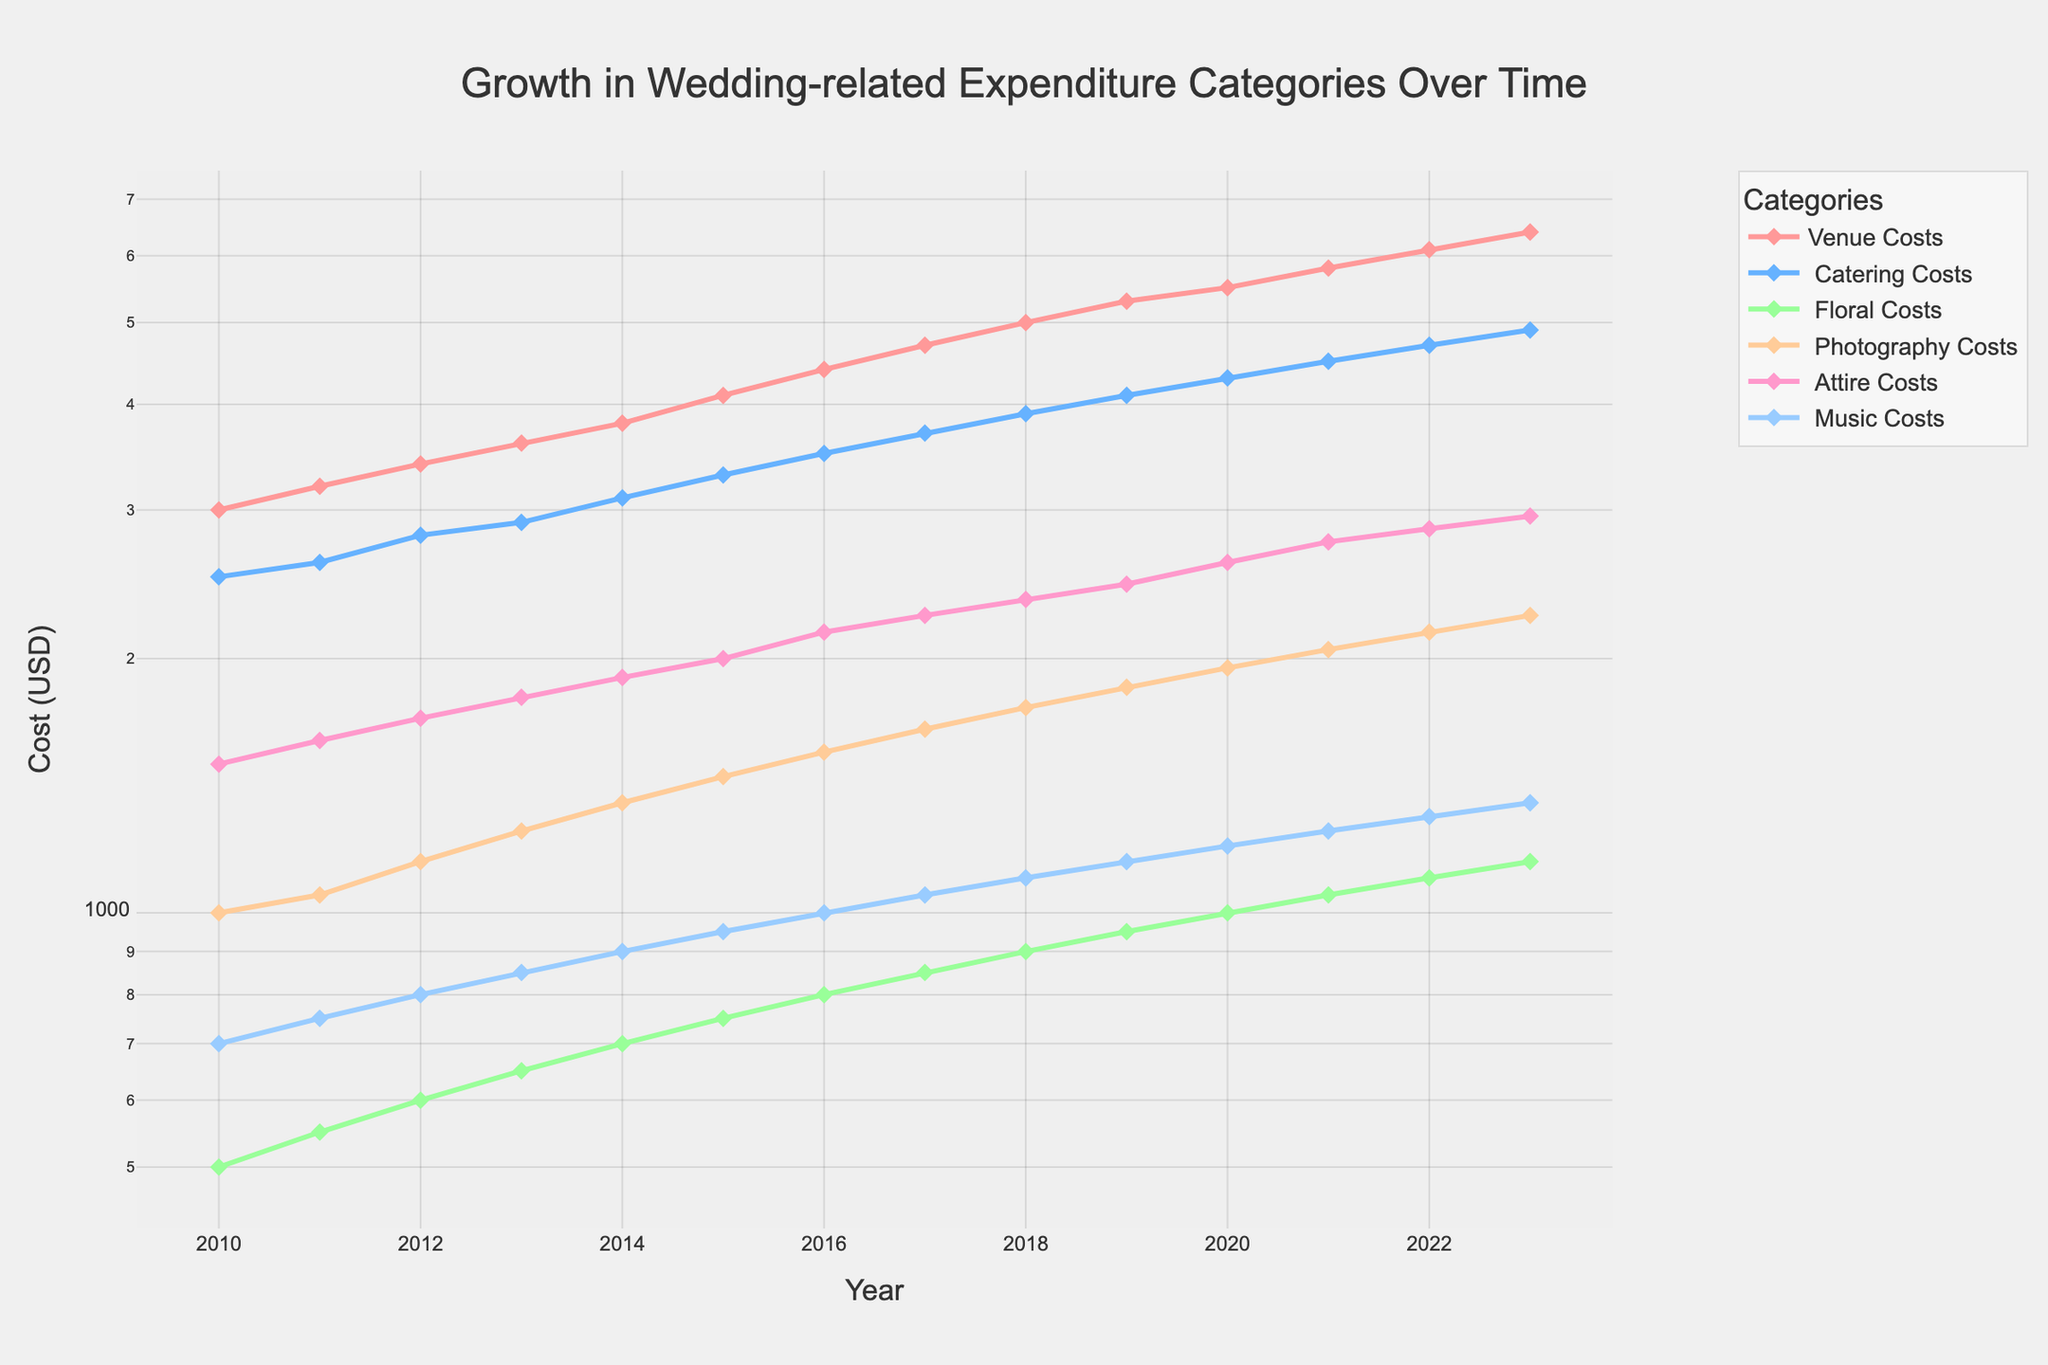what is the title of the plot? The title of the plot is usually located at the top center of the figure. The title here summarizes what the plot is about.
Answer: Growth in Wedding-related Expenditure Categories Over Time Which category had the highest cost in 2023? To determine which category had the highest cost in 2023, look at the data points for the year 2023 across all categories and identify the one with the highest value.
Answer: Venue Costs How much has the cost of floral arrangements increased from 2010 to 2023? Look at the values for Floral Costs in 2010 and 2023, then subtract the 2010 value from the 2023 value. (1150 - 500 = 650).
Answer: 650 Which expenditure category shows the steepest growth over time? Compare the slopes of the lines for each category. The steepest line represents the category with the steepest growth.
Answer: Venue Costs How do the attire costs in 2019 compare to 2023? Compare the values for Attire Costs in both years. (2023: 2950 vs 2019: 2450).
Answer: Costs increased by 500 By what percentage did Music Costs increase from 2010 to 2023? First, calculate the increase in Music Costs (1350 - 700 = 650) and then divide by the 2010 cost to find the percentage increase (650 / 700 * 100 ≈ 92.86%).
Answer: 92.86% Which year experienced the highest increase in Venue Costs? Calculate the year-to-year difference for Venue Costs and identify the year with the largest increase. The largest difference comes between consecutive years. Compare (2015 to 2016: 4400 - 4100 = 300) and others.
Answer: 2015-2016 Are Catering Costs or Photography Costs higher in 2020? Compare the values for both categories in 2020. Catering Costs: 4300, Photography Costs: 1950.
Answer: Catering Costs What is the trend of Floral Costs over time? Observe the line representing Floral Costs from 2010 to 2023. It exhibits a steady upward trend.
Answer: Steadily increasing How do Venue Costs in 2012 compare proportionally to Music Costs in the same year? Find the values for both categories in 2012 (Venue Costs: 3400, Music Costs: 800). Divide the Venue Costs by the Music Costs (3400 / 800 = 4.25).
Answer: 4.25 times higher 